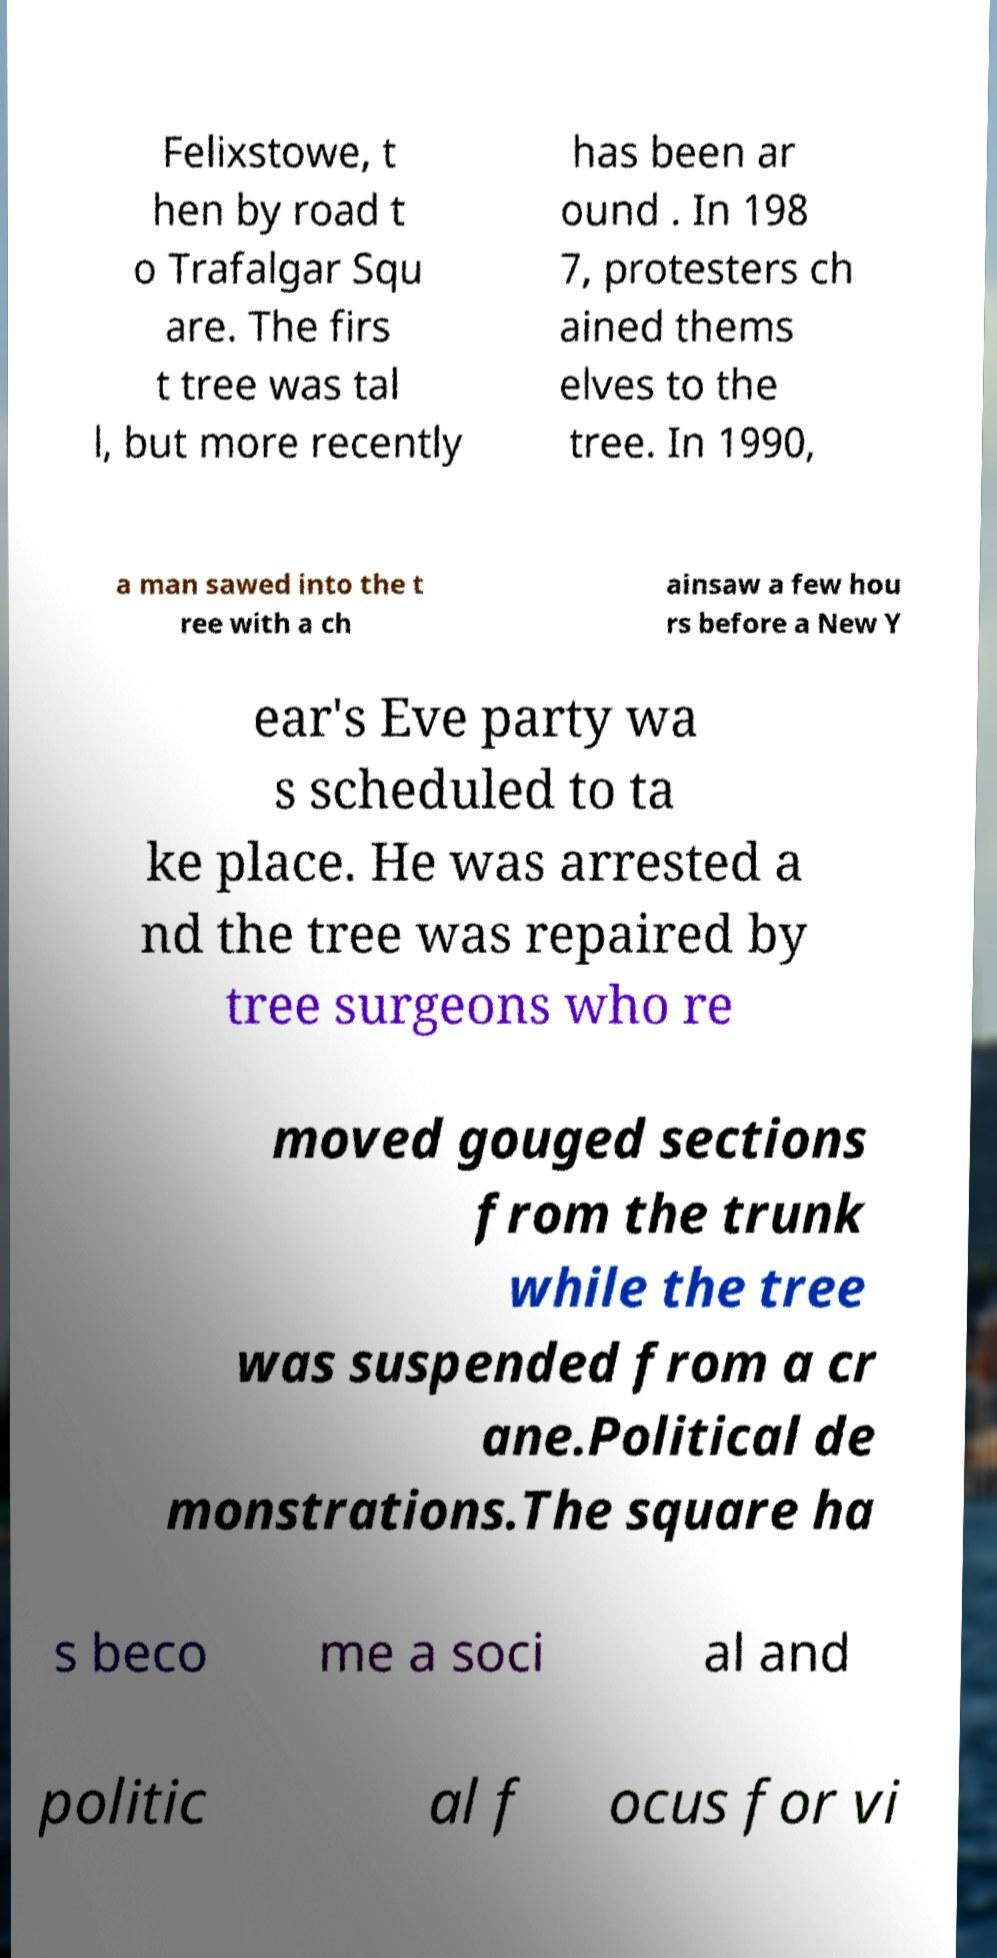Please identify and transcribe the text found in this image. Felixstowe, t hen by road t o Trafalgar Squ are. The firs t tree was tal l, but more recently has been ar ound . In 198 7, protesters ch ained thems elves to the tree. In 1990, a man sawed into the t ree with a ch ainsaw a few hou rs before a New Y ear's Eve party wa s scheduled to ta ke place. He was arrested a nd the tree was repaired by tree surgeons who re moved gouged sections from the trunk while the tree was suspended from a cr ane.Political de monstrations.The square ha s beco me a soci al and politic al f ocus for vi 